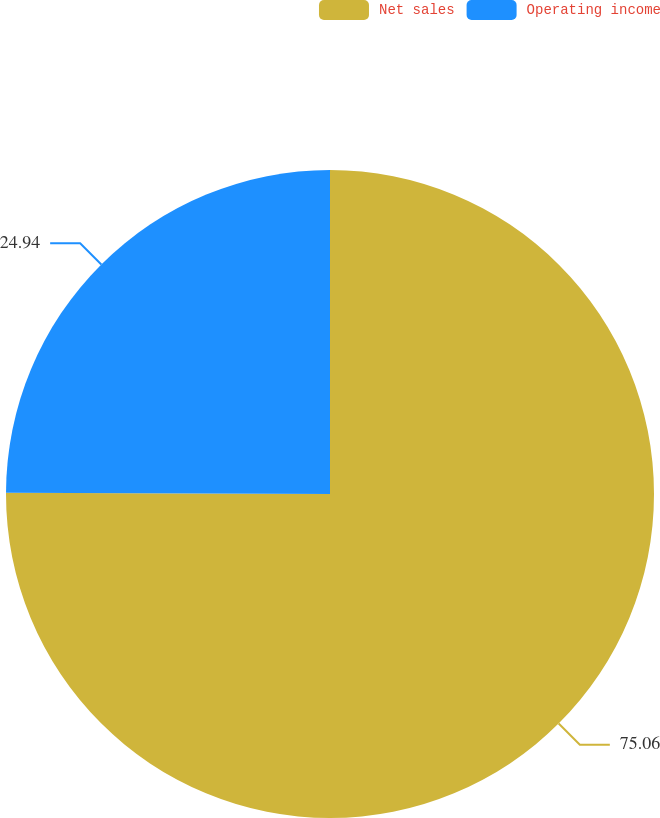<chart> <loc_0><loc_0><loc_500><loc_500><pie_chart><fcel>Net sales<fcel>Operating income<nl><fcel>75.06%<fcel>24.94%<nl></chart> 